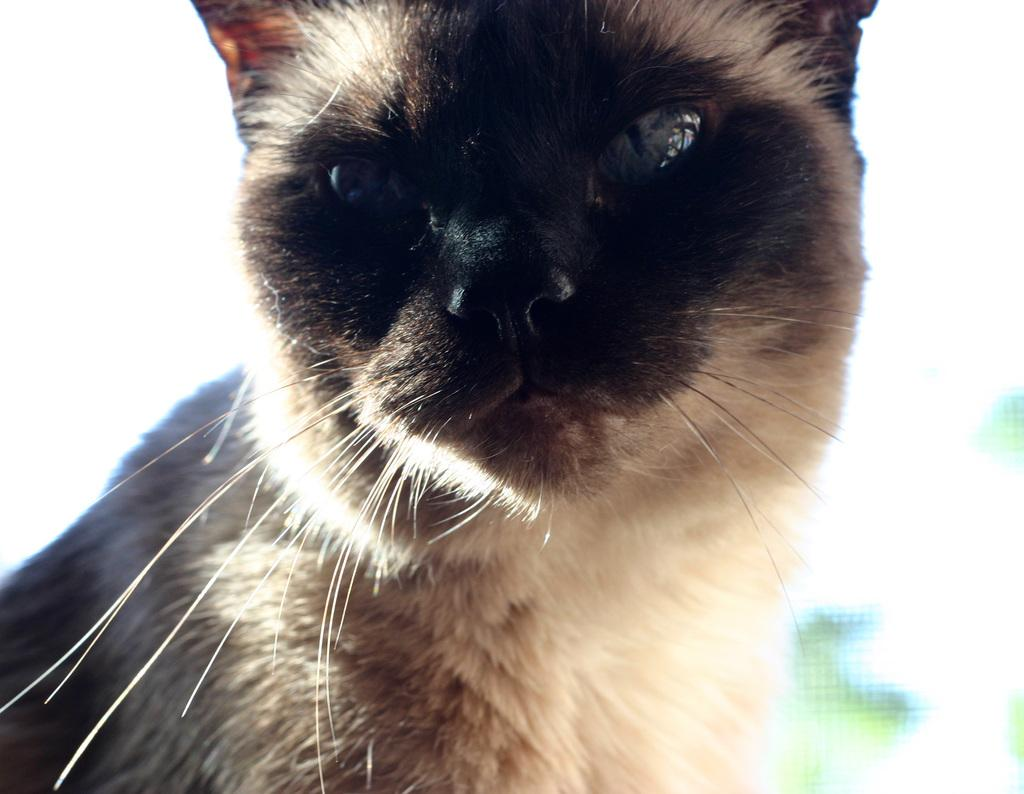What type of animal is in the image? There is a cat in the image. Can you describe the background of the image? The background of the image is blurry. How many bikes are parked on the street in the image? There are no bikes or streets present in the image; it features a cat with a blurry background. 